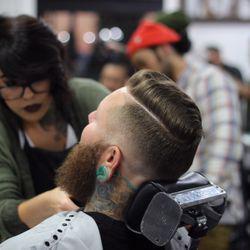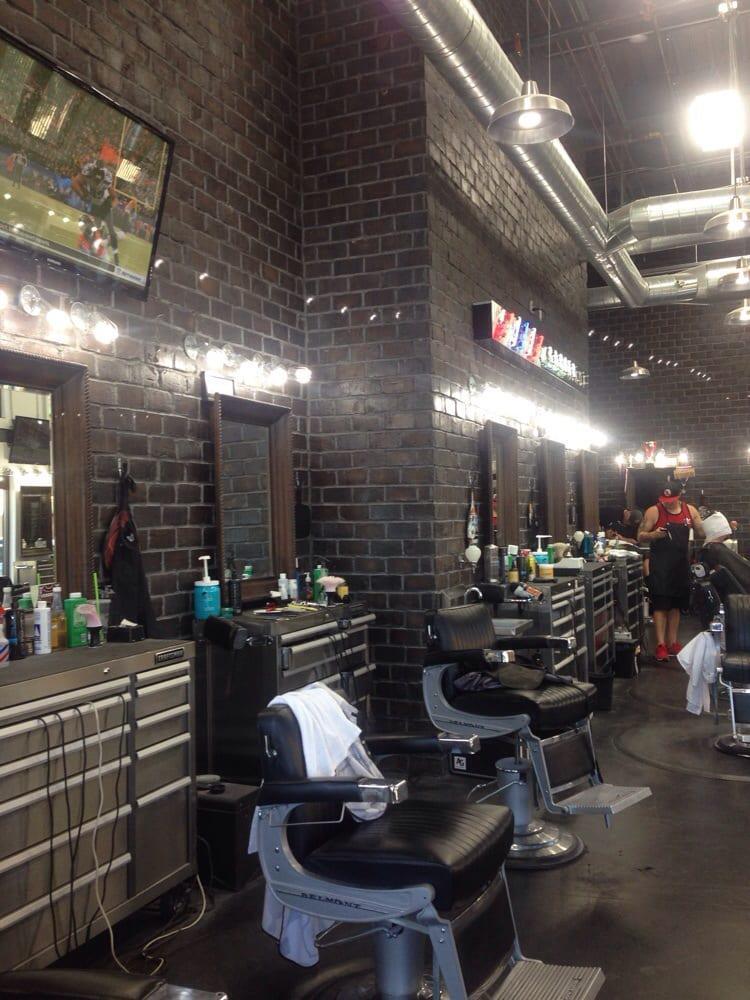The first image is the image on the left, the second image is the image on the right. Evaluate the accuracy of this statement regarding the images: "Black barber chairs are empty in one image.". Is it true? Answer yes or no. Yes. 